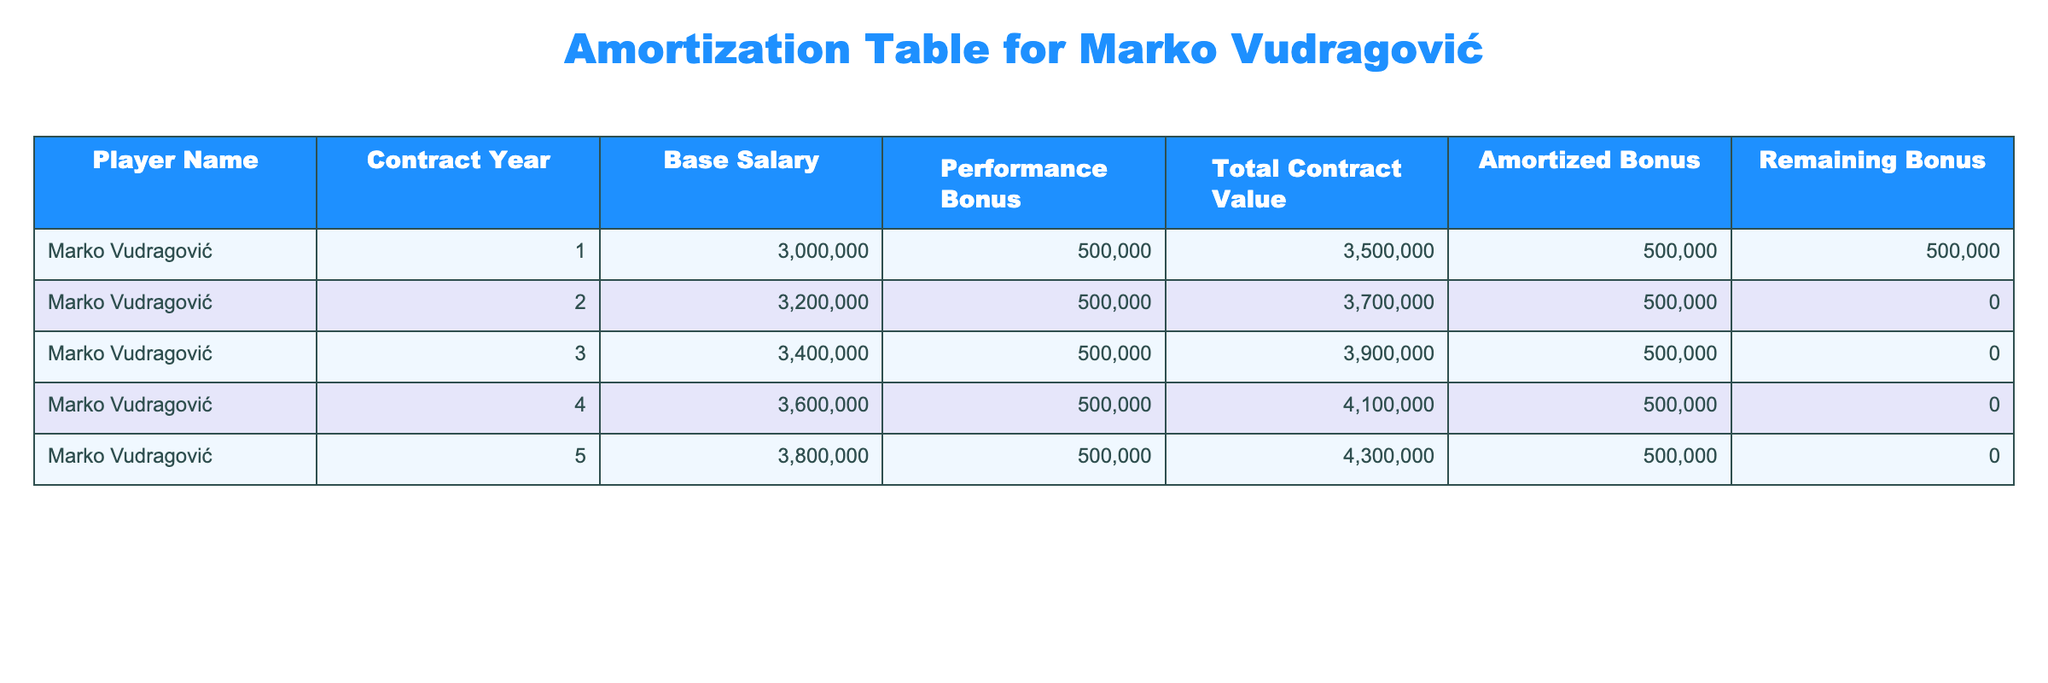What is the base salary for Marko Vudragović in his third contract year? According to the table, the "Base Salary" for Marko Vudragović in Contract Year 3 is shown as 3,400,000.
Answer: 3,400,000 How much total contract value does Marko Vudragović have in his fourth year? The "Total Contract Value" for Marko Vudragović in Contract Year 4 is listed as 4,100,000.
Answer: 4,100,000 What is the total amount of performance bonuses for Marko Vudragović over the five years of his contract? Marko Vudragović receives a performance bonus of 500,000 each year for five years, so the total is calculated as 500,000 * 5 = 2,500,000.
Answer: 2,500,000 Does Marko Vudragović have any remaining bonuses at the end of his contract in year five? The table shows that the "Remaining Bonus" for Marko Vudragović in Contract Year 5 is 0, indicating he has used all bonuses by the end of the contract.
Answer: No What is the total amount of the amortized bonus by the end of each contract year? The amortized bonus each year is consistently 500,000, and with five years total, the cumulative amortized bonus at the end of each year is as follows: Year 1: 500,000, Year 2: 1,000,000, Year 3: 1,500,000, Year 4: 2,000,000, and Year 5: 2,500,000.
Answer: Year 5 total is 2,500,000 In which contract year does Marko Vudragović stop receiving performance bonuses? According to the table, the performance bonuses are received every year, and by the end of Year 5, the remaining bonus is 0, indicating he stopped receiving bonuses after the fifth year.
Answer: Year 5 What is the increase in base salary from Year 1 to Year 5? The base salary increased from 3,000,000 in Year 1 to 3,800,000 in Year 5. To find the increase, we subtract the Year 1 salary from Year 5: 3,800,000 - 3,000,000 = 800,000.
Answer: 800,000 How would the total contract value change if the performance bonus were doubled each year? If the performance bonus were doubled to 1,000,000 each year, the total contract value for each year would be increased by an additional 500,000. Thus, the new total contract values for years 1-5 would be 4,000,000, 4,200,000, 4,400,000, 4,600,000, and 4,800,000 respectively, which cumulatively is a significant increase from the original values.
Answer: The values will increase to a maximum of 4,800,000 